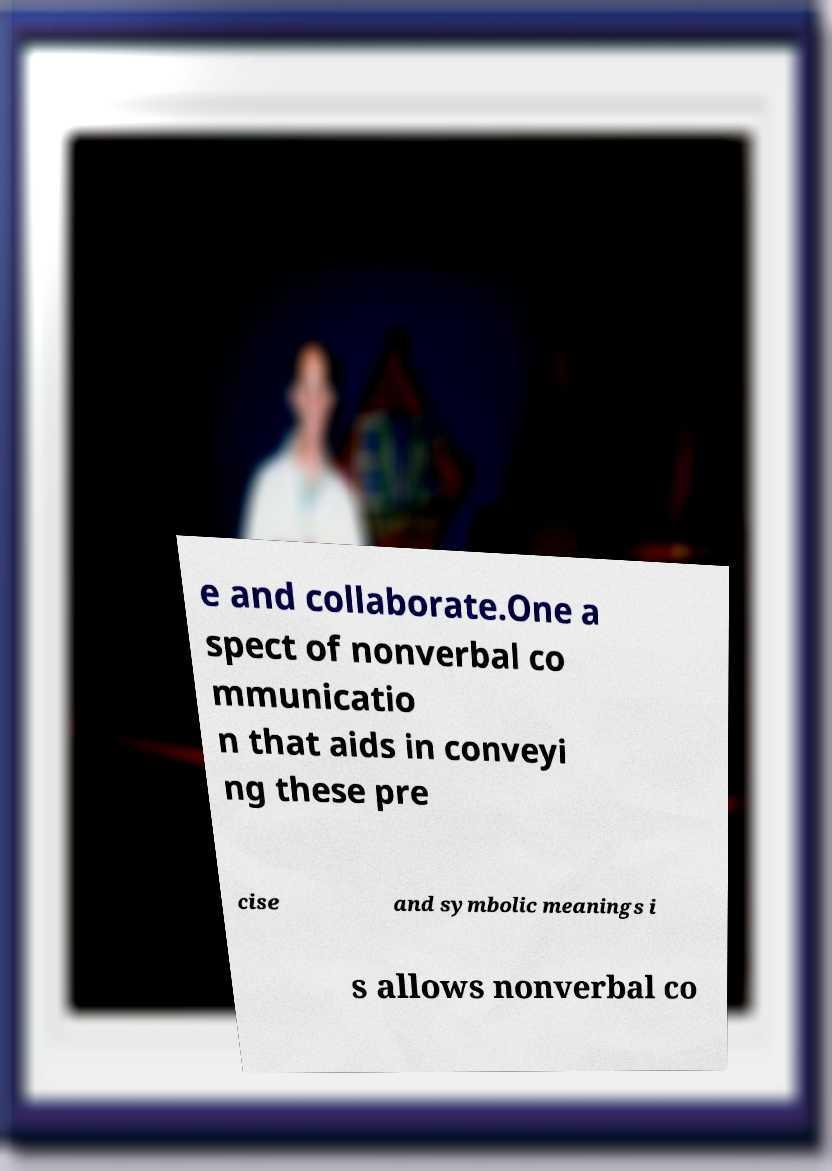For documentation purposes, I need the text within this image transcribed. Could you provide that? e and collaborate.One a spect of nonverbal co mmunicatio n that aids in conveyi ng these pre cise and symbolic meanings i s allows nonverbal co 